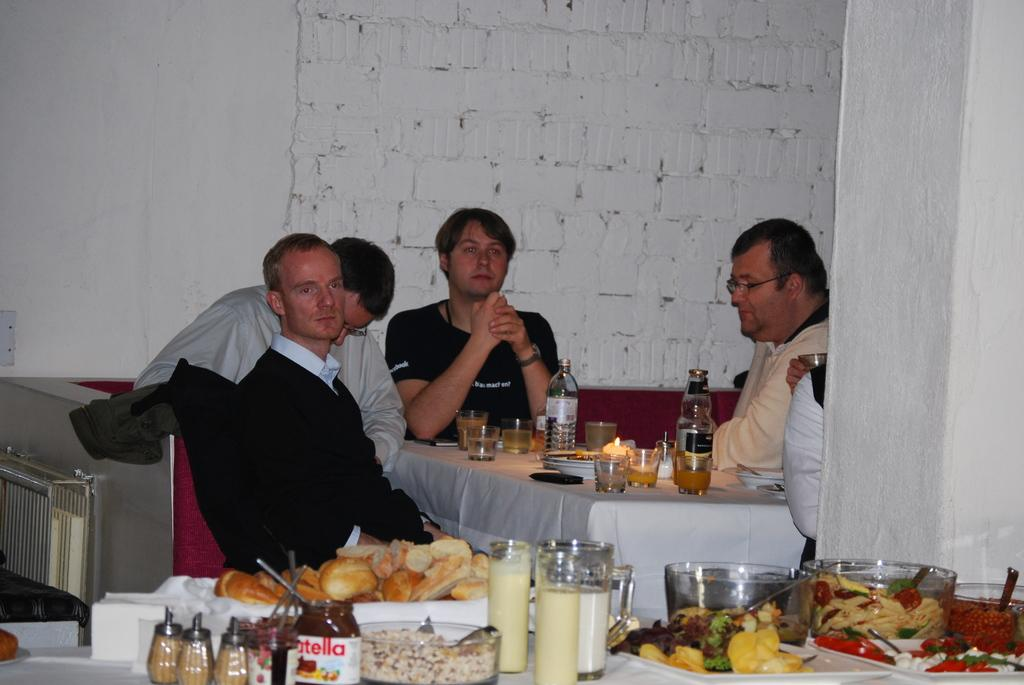<image>
Relay a brief, clear account of the picture shown. Several men sigging in a booth in a restaurant with a bottle of nutella on the table next to them. 